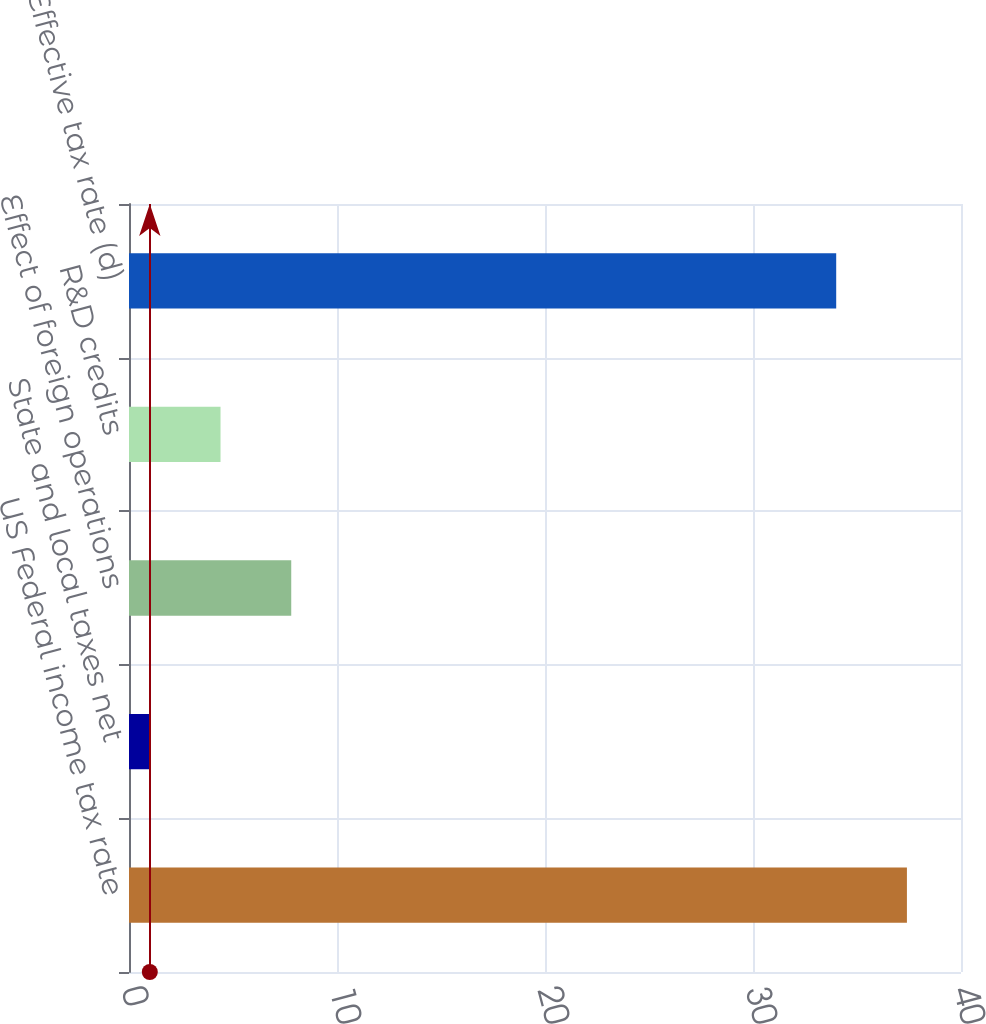Convert chart. <chart><loc_0><loc_0><loc_500><loc_500><bar_chart><fcel>US Federal income tax rate<fcel>State and local taxes net<fcel>Effect of foreign operations<fcel>R&D credits<fcel>Effective tax rate (d)<nl><fcel>37.4<fcel>1<fcel>7.8<fcel>4.4<fcel>34<nl></chart> 